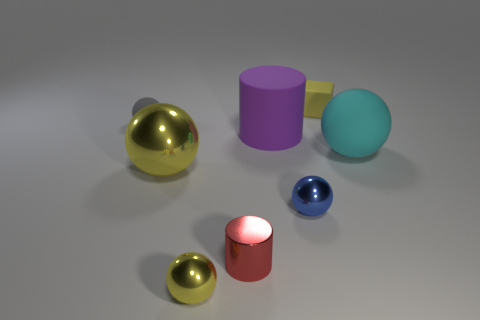Subtract all cyan spheres. How many spheres are left? 4 Subtract 1 spheres. How many spheres are left? 4 Subtract all small gray spheres. How many spheres are left? 4 Subtract all green spheres. Subtract all cyan cylinders. How many spheres are left? 5 Add 1 matte objects. How many objects exist? 9 Subtract all cubes. How many objects are left? 7 Add 7 gray matte things. How many gray matte things are left? 8 Add 3 small yellow metallic objects. How many small yellow metallic objects exist? 4 Subtract 1 yellow blocks. How many objects are left? 7 Subtract all small purple things. Subtract all yellow balls. How many objects are left? 6 